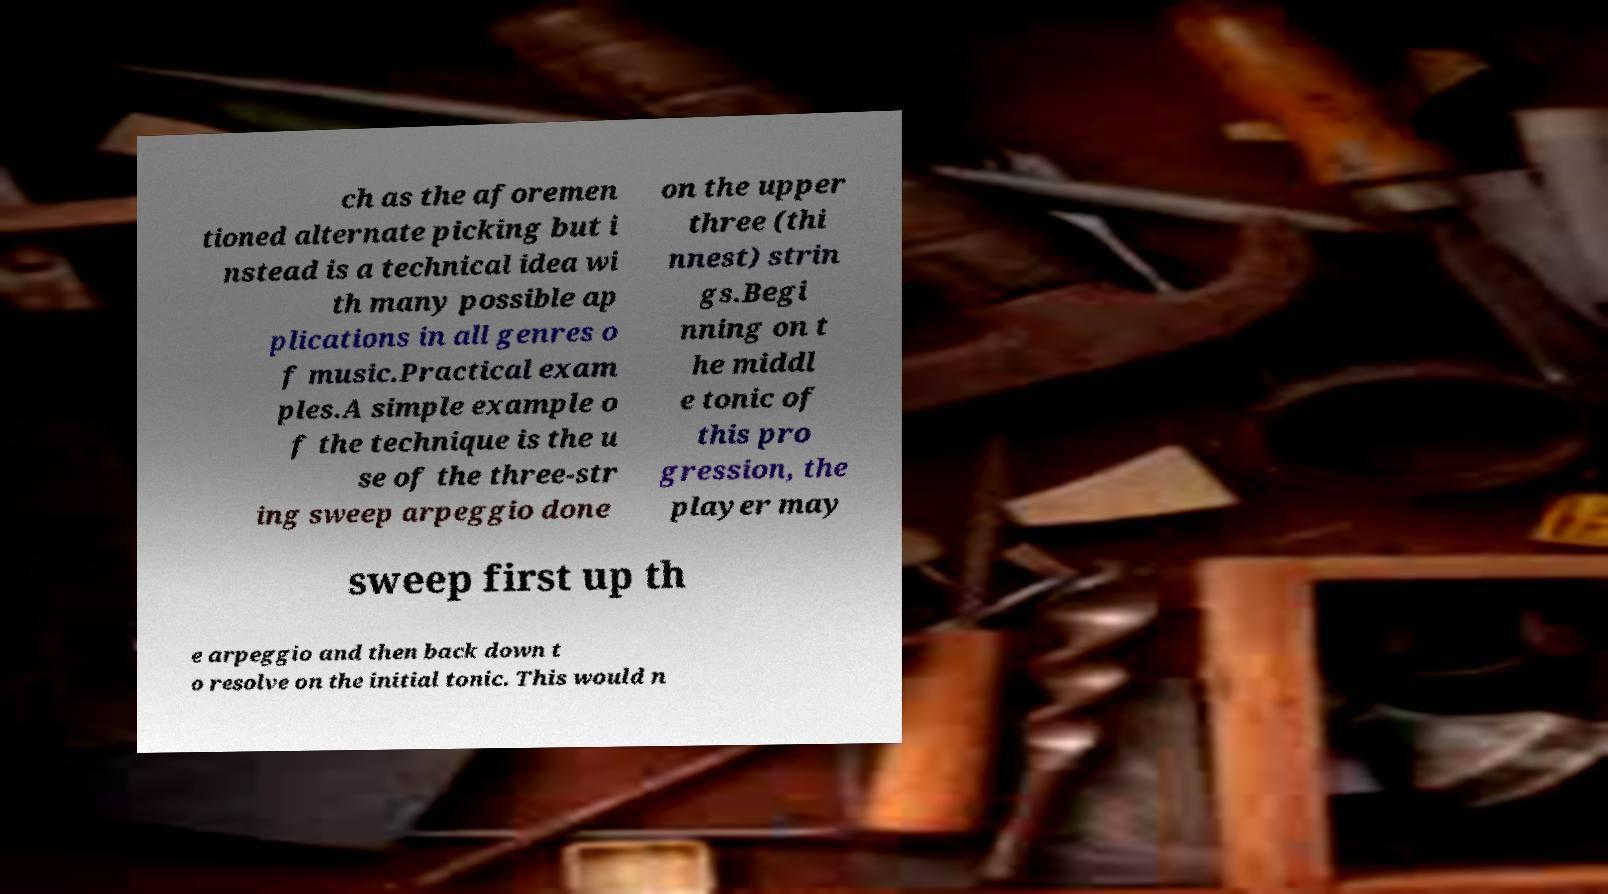For documentation purposes, I need the text within this image transcribed. Could you provide that? ch as the aforemen tioned alternate picking but i nstead is a technical idea wi th many possible ap plications in all genres o f music.Practical exam ples.A simple example o f the technique is the u se of the three-str ing sweep arpeggio done on the upper three (thi nnest) strin gs.Begi nning on t he middl e tonic of this pro gression, the player may sweep first up th e arpeggio and then back down t o resolve on the initial tonic. This would n 